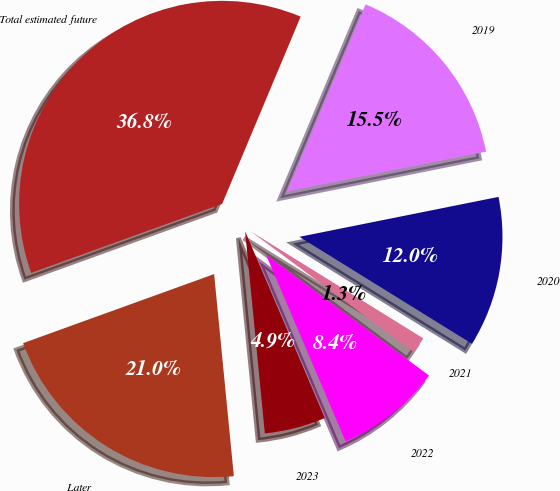<chart> <loc_0><loc_0><loc_500><loc_500><pie_chart><fcel>2019<fcel>2020<fcel>2021<fcel>2022<fcel>2023<fcel>Later<fcel>Total estimated future<nl><fcel>15.53%<fcel>11.98%<fcel>1.32%<fcel>8.43%<fcel>4.87%<fcel>21.03%<fcel>36.84%<nl></chart> 